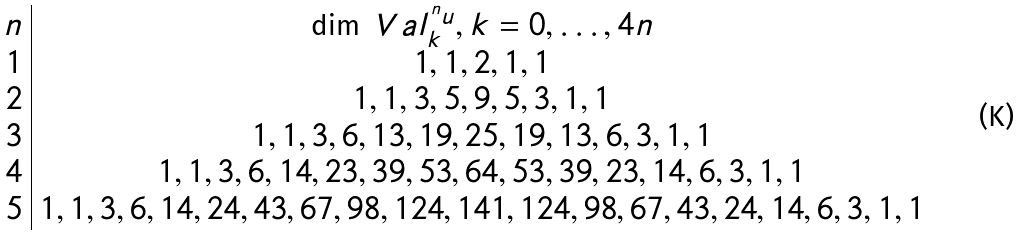<formula> <loc_0><loc_0><loc_500><loc_500>\begin{array} { c | c } n & \dim \ V a l _ { k } ^ { ^ { n } u } , k = 0 , \dots , 4 n \\ 1 & 1 , 1 , 2 , 1 , 1 \\ 2 & 1 , 1 , 3 , 5 , 9 , 5 , 3 , 1 , 1 \\ 3 & 1 , 1 , 3 , 6 , 1 3 , 1 9 , 2 5 , 1 9 , 1 3 , 6 , 3 , 1 , 1 \\ 4 & 1 , 1 , 3 , 6 , 1 4 , 2 3 , 3 9 , 5 3 , 6 4 , 5 3 , 3 9 , 2 3 , 1 4 , 6 , 3 , 1 , 1 \\ 5 & 1 , 1 , 3 , 6 , 1 4 , 2 4 , 4 3 , 6 7 , 9 8 , 1 2 4 , 1 4 1 , 1 2 4 , 9 8 , 6 7 , 4 3 , 2 4 , 1 4 , 6 , 3 , 1 , 1 \end{array}</formula> 